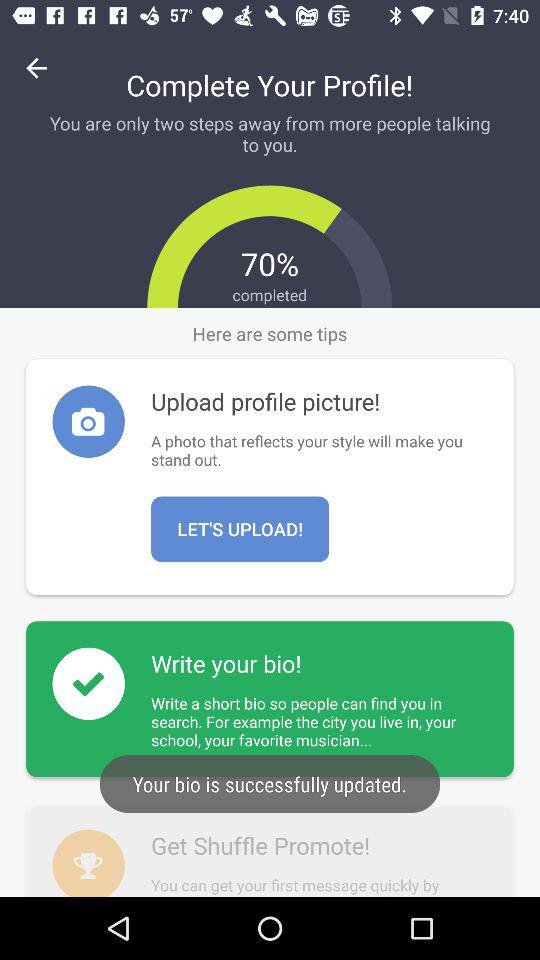What percentage of my profile is complete?
Answer the question using a single word or phrase. 70% 